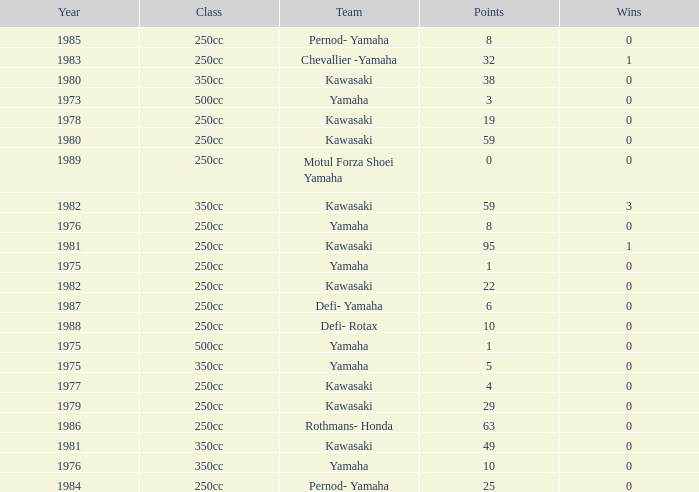What is the mean year number where there are more than 0 wins, the class is 250cc, and the points are 95? 1981.0. 